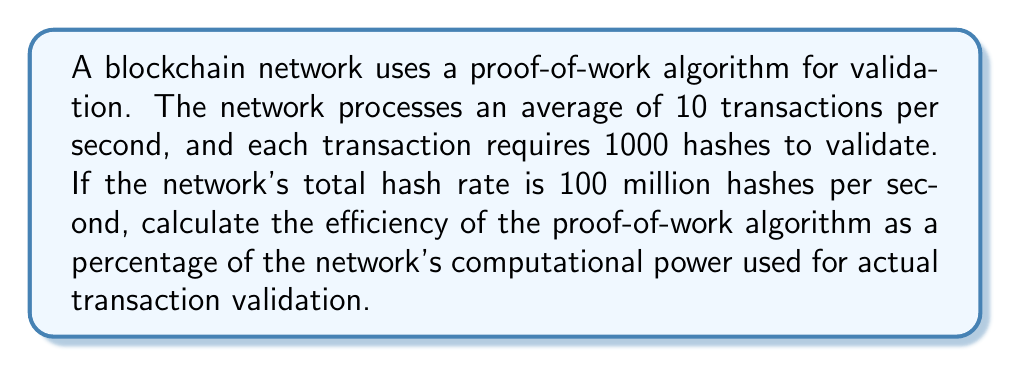Provide a solution to this math problem. To calculate the efficiency of the proof-of-work algorithm, we need to determine the percentage of computational power used for actual transaction validation compared to the total computational power of the network. Let's break it down step-by-step:

1. Calculate the number of hashes required for transaction validation per second:
   $$ \text{Hashes for validation} = \text{Transactions per second} \times \text{Hashes per transaction} $$
   $$ = 10 \times 1000 = 10,000 \text{ hashes/second} $$

2. Calculate the total hash rate of the network:
   $$ \text{Total hash rate} = 100 \text{ million hashes/second} = 100,000,000 \text{ hashes/second} $$

3. Calculate the efficiency as a percentage:
   $$ \text{Efficiency} = \frac{\text{Hashes for validation}}{\text{Total hash rate}} \times 100\% $$
   $$ = \frac{10,000}{100,000,000} \times 100\% $$
   $$ = 0.01\% $$

This means that only 0.01% of the network's computational power is used for actual transaction validation, while the remaining 99.99% is used for the competitive mining process.
Answer: 0.01% 